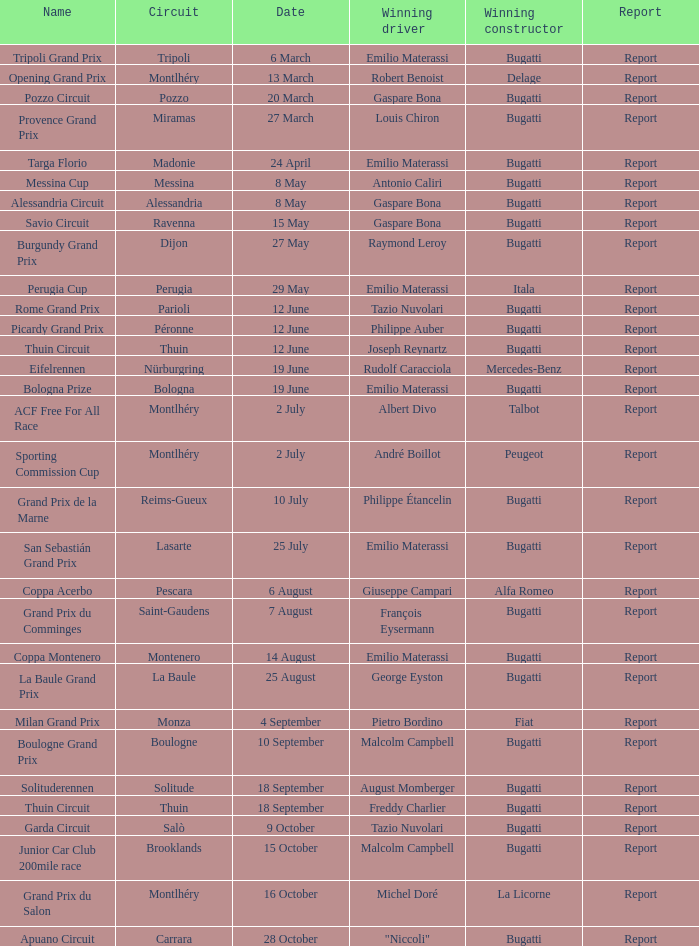Which specific circuit did françois eysermann achieve a win? Saint-Gaudens. 